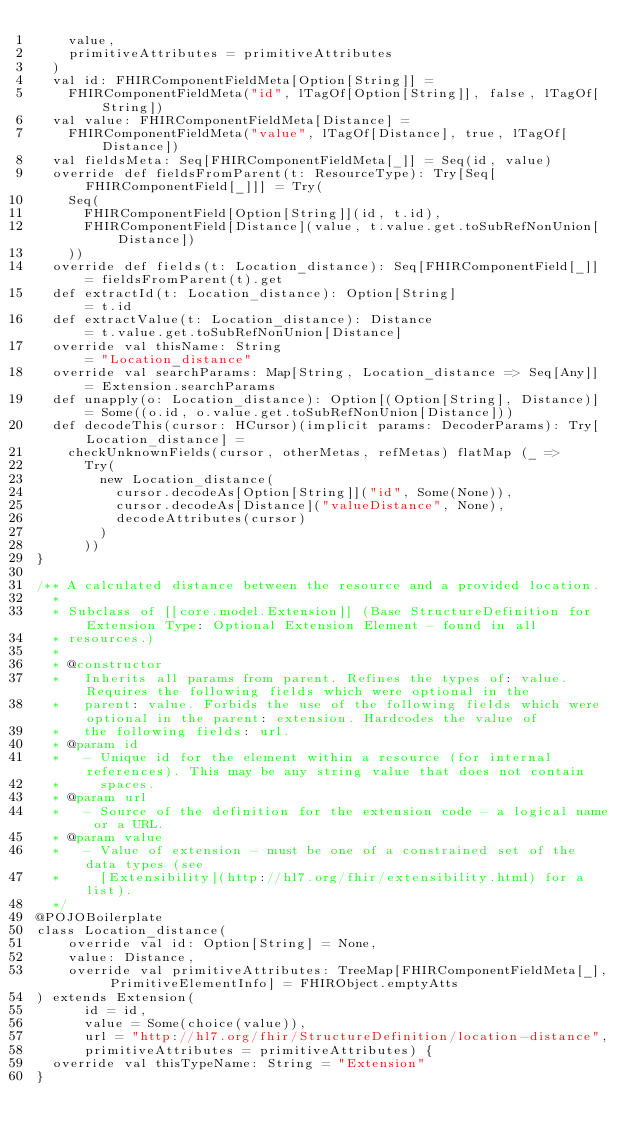Convert code to text. <code><loc_0><loc_0><loc_500><loc_500><_Scala_>    value,
    primitiveAttributes = primitiveAttributes
  )
  val id: FHIRComponentFieldMeta[Option[String]] =
    FHIRComponentFieldMeta("id", lTagOf[Option[String]], false, lTagOf[String])
  val value: FHIRComponentFieldMeta[Distance] =
    FHIRComponentFieldMeta("value", lTagOf[Distance], true, lTagOf[Distance])
  val fieldsMeta: Seq[FHIRComponentFieldMeta[_]] = Seq(id, value)
  override def fieldsFromParent(t: ResourceType): Try[Seq[FHIRComponentField[_]]] = Try(
    Seq(
      FHIRComponentField[Option[String]](id, t.id),
      FHIRComponentField[Distance](value, t.value.get.toSubRefNonUnion[Distance])
    ))
  override def fields(t: Location_distance): Seq[FHIRComponentField[_]] = fieldsFromParent(t).get
  def extractId(t: Location_distance): Option[String]                   = t.id
  def extractValue(t: Location_distance): Distance                      = t.value.get.toSubRefNonUnion[Distance]
  override val thisName: String                                         = "Location_distance"
  override val searchParams: Map[String, Location_distance => Seq[Any]] = Extension.searchParams
  def unapply(o: Location_distance): Option[(Option[String], Distance)] = Some((o.id, o.value.get.toSubRefNonUnion[Distance]))
  def decodeThis(cursor: HCursor)(implicit params: DecoderParams): Try[Location_distance] =
    checkUnknownFields(cursor, otherMetas, refMetas) flatMap (_ =>
      Try(
        new Location_distance(
          cursor.decodeAs[Option[String]]("id", Some(None)),
          cursor.decodeAs[Distance]("valueDistance", None),
          decodeAttributes(cursor)
        )
      ))
}

/** A calculated distance between the resource and a provided location.
  *
  * Subclass of [[core.model.Extension]] (Base StructureDefinition for Extension Type: Optional Extension Element - found in all
  * resources.)
  *
  * @constructor
  *   Inherits all params from parent. Refines the types of: value. Requires the following fields which were optional in the
  *   parent: value. Forbids the use of the following fields which were optional in the parent: extension. Hardcodes the value of
  *   the following fields: url.
  * @param id
  *   - Unique id for the element within a resource (for internal references). This may be any string value that does not contain
  *     spaces.
  * @param url
  *   - Source of the definition for the extension code - a logical name or a URL.
  * @param value
  *   - Value of extension - must be one of a constrained set of the data types (see
  *     [Extensibility](http://hl7.org/fhir/extensibility.html) for a list).
  */
@POJOBoilerplate
class Location_distance(
    override val id: Option[String] = None,
    value: Distance,
    override val primitiveAttributes: TreeMap[FHIRComponentFieldMeta[_], PrimitiveElementInfo] = FHIRObject.emptyAtts
) extends Extension(
      id = id,
      value = Some(choice(value)),
      url = "http://hl7.org/fhir/StructureDefinition/location-distance",
      primitiveAttributes = primitiveAttributes) {
  override val thisTypeName: String = "Extension"
}
</code> 